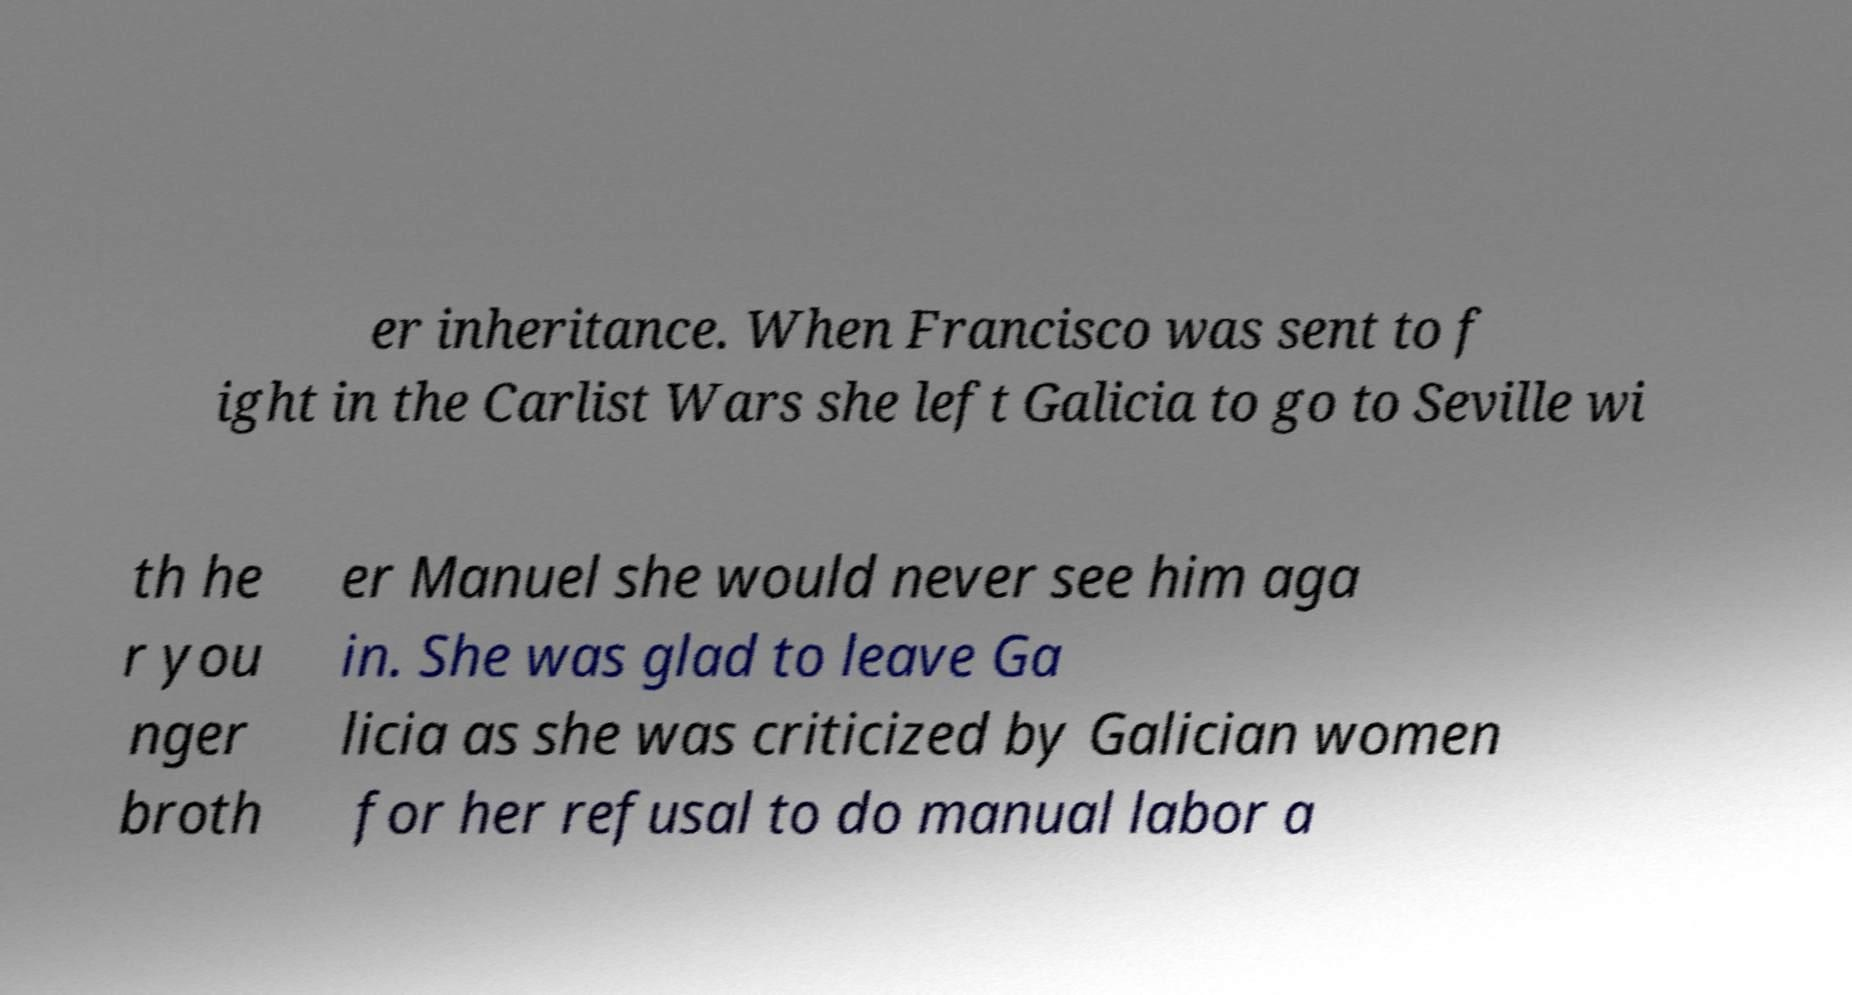Could you assist in decoding the text presented in this image and type it out clearly? er inheritance. When Francisco was sent to f ight in the Carlist Wars she left Galicia to go to Seville wi th he r you nger broth er Manuel she would never see him aga in. She was glad to leave Ga licia as she was criticized by Galician women for her refusal to do manual labor a 